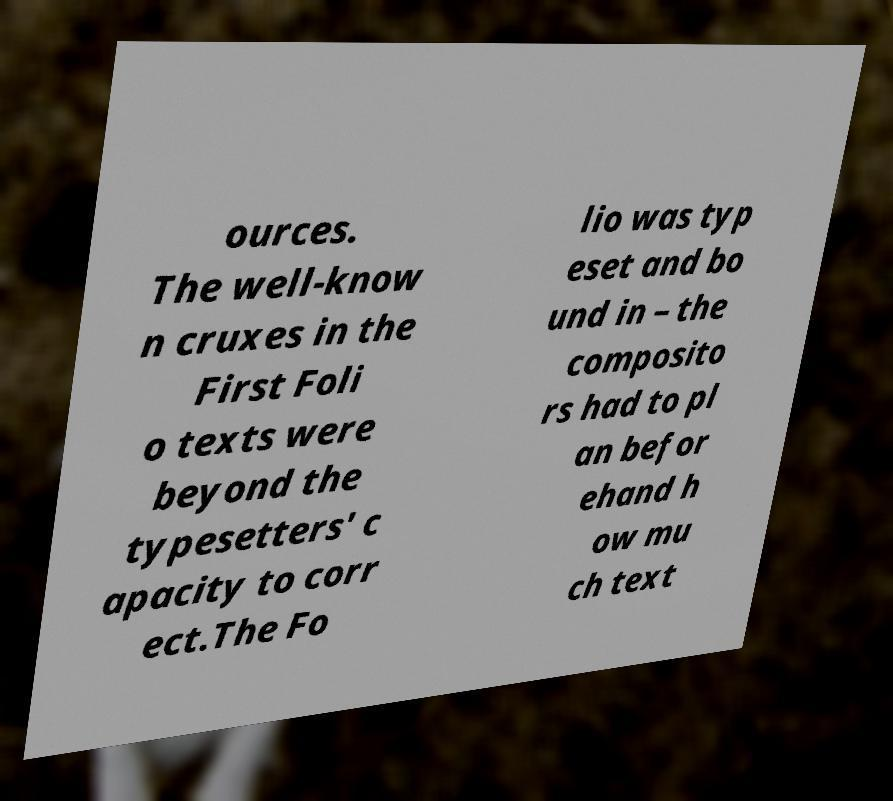Could you assist in decoding the text presented in this image and type it out clearly? ources. The well-know n cruxes in the First Foli o texts were beyond the typesetters' c apacity to corr ect.The Fo lio was typ eset and bo und in – the composito rs had to pl an befor ehand h ow mu ch text 